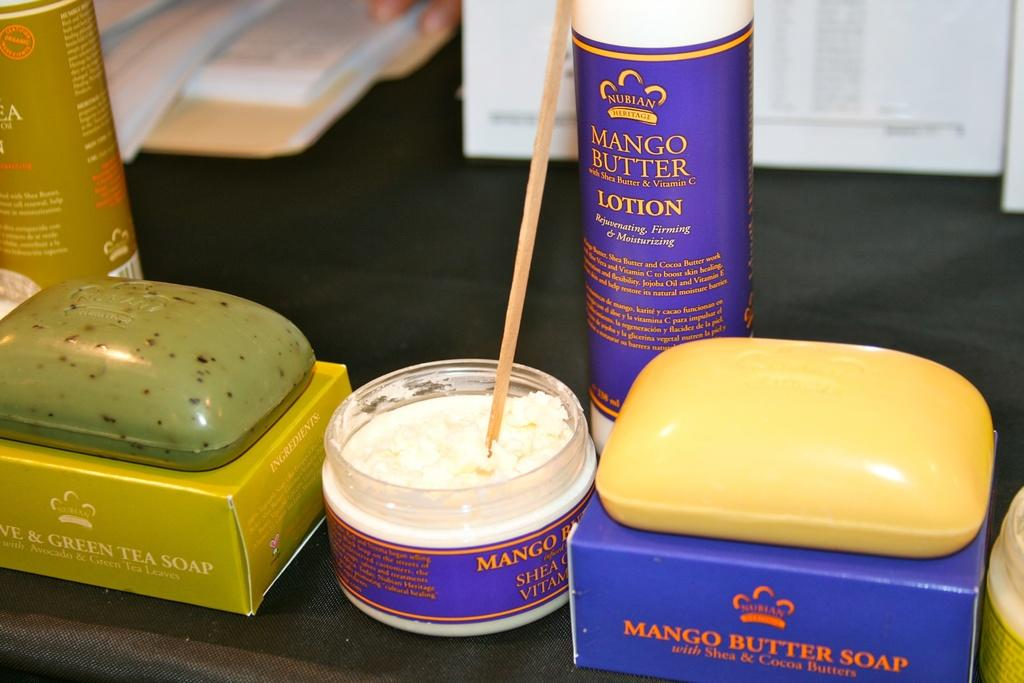Provide a one-sentence caption for the provided image. A close up of a selection of Mango and Green Tea soaps and lotions. 